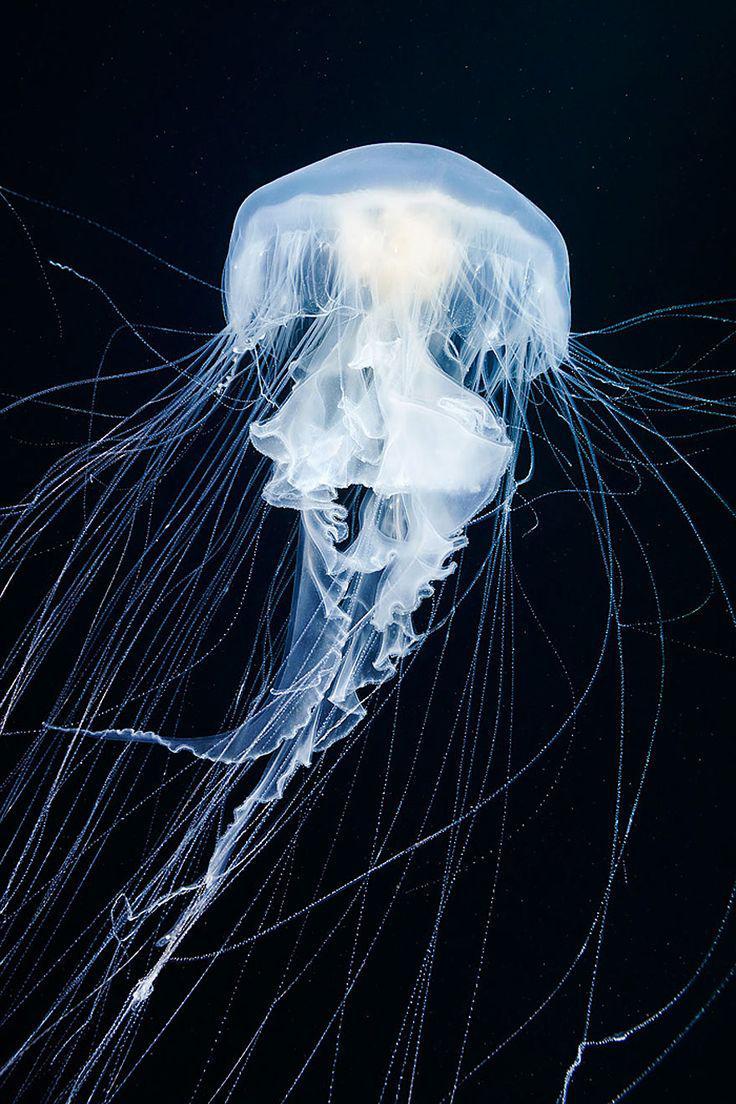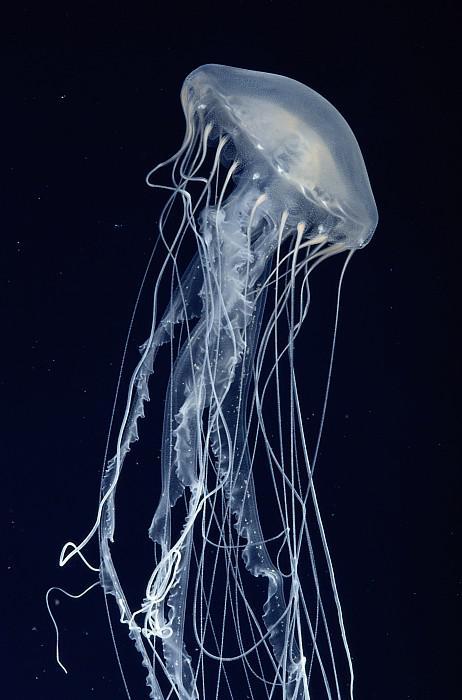The first image is the image on the left, the second image is the image on the right. Given the left and right images, does the statement "Each image shows a translucent bluish-white jellyfish shaped like a mushroom, with threadlike and ruffly tentacles trailing under it." hold true? Answer yes or no. Yes. The first image is the image on the left, the second image is the image on the right. For the images displayed, is the sentence "In at least one image there is on blue lit jellyfish whose head cap is straight up and down." factually correct? Answer yes or no. Yes. 